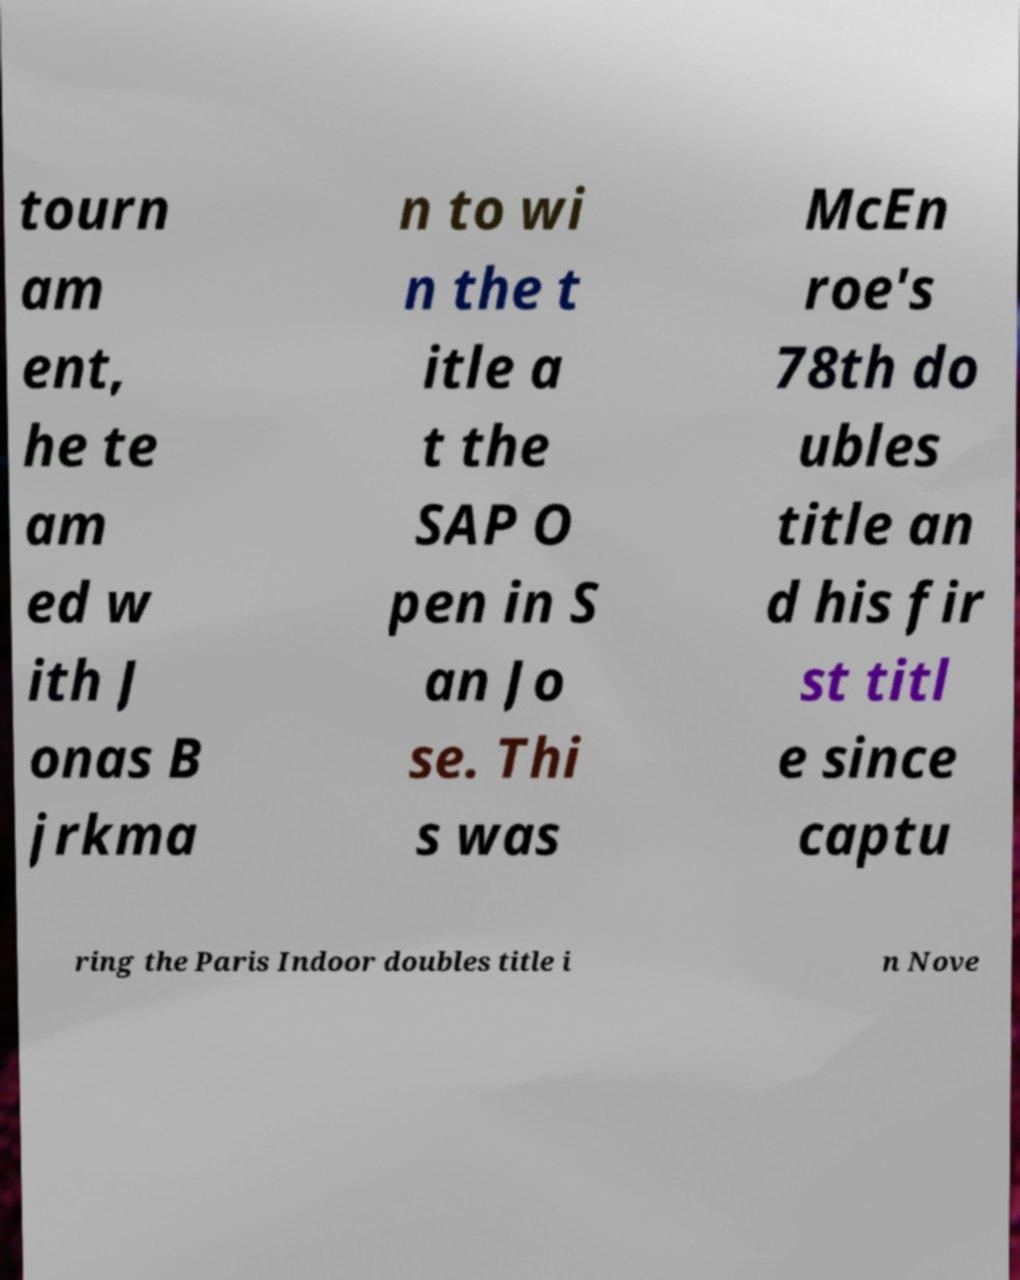Could you extract and type out the text from this image? tourn am ent, he te am ed w ith J onas B jrkma n to wi n the t itle a t the SAP O pen in S an Jo se. Thi s was McEn roe's 78th do ubles title an d his fir st titl e since captu ring the Paris Indoor doubles title i n Nove 